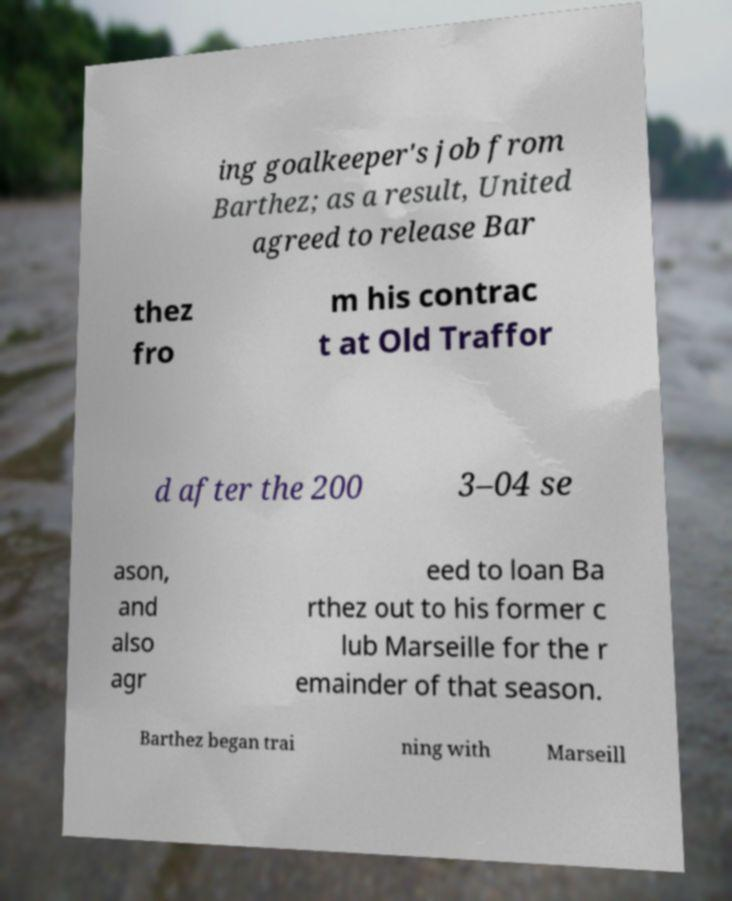Please read and relay the text visible in this image. What does it say? ing goalkeeper's job from Barthez; as a result, United agreed to release Bar thez fro m his contrac t at Old Traffor d after the 200 3–04 se ason, and also agr eed to loan Ba rthez out to his former c lub Marseille for the r emainder of that season. Barthez began trai ning with Marseill 